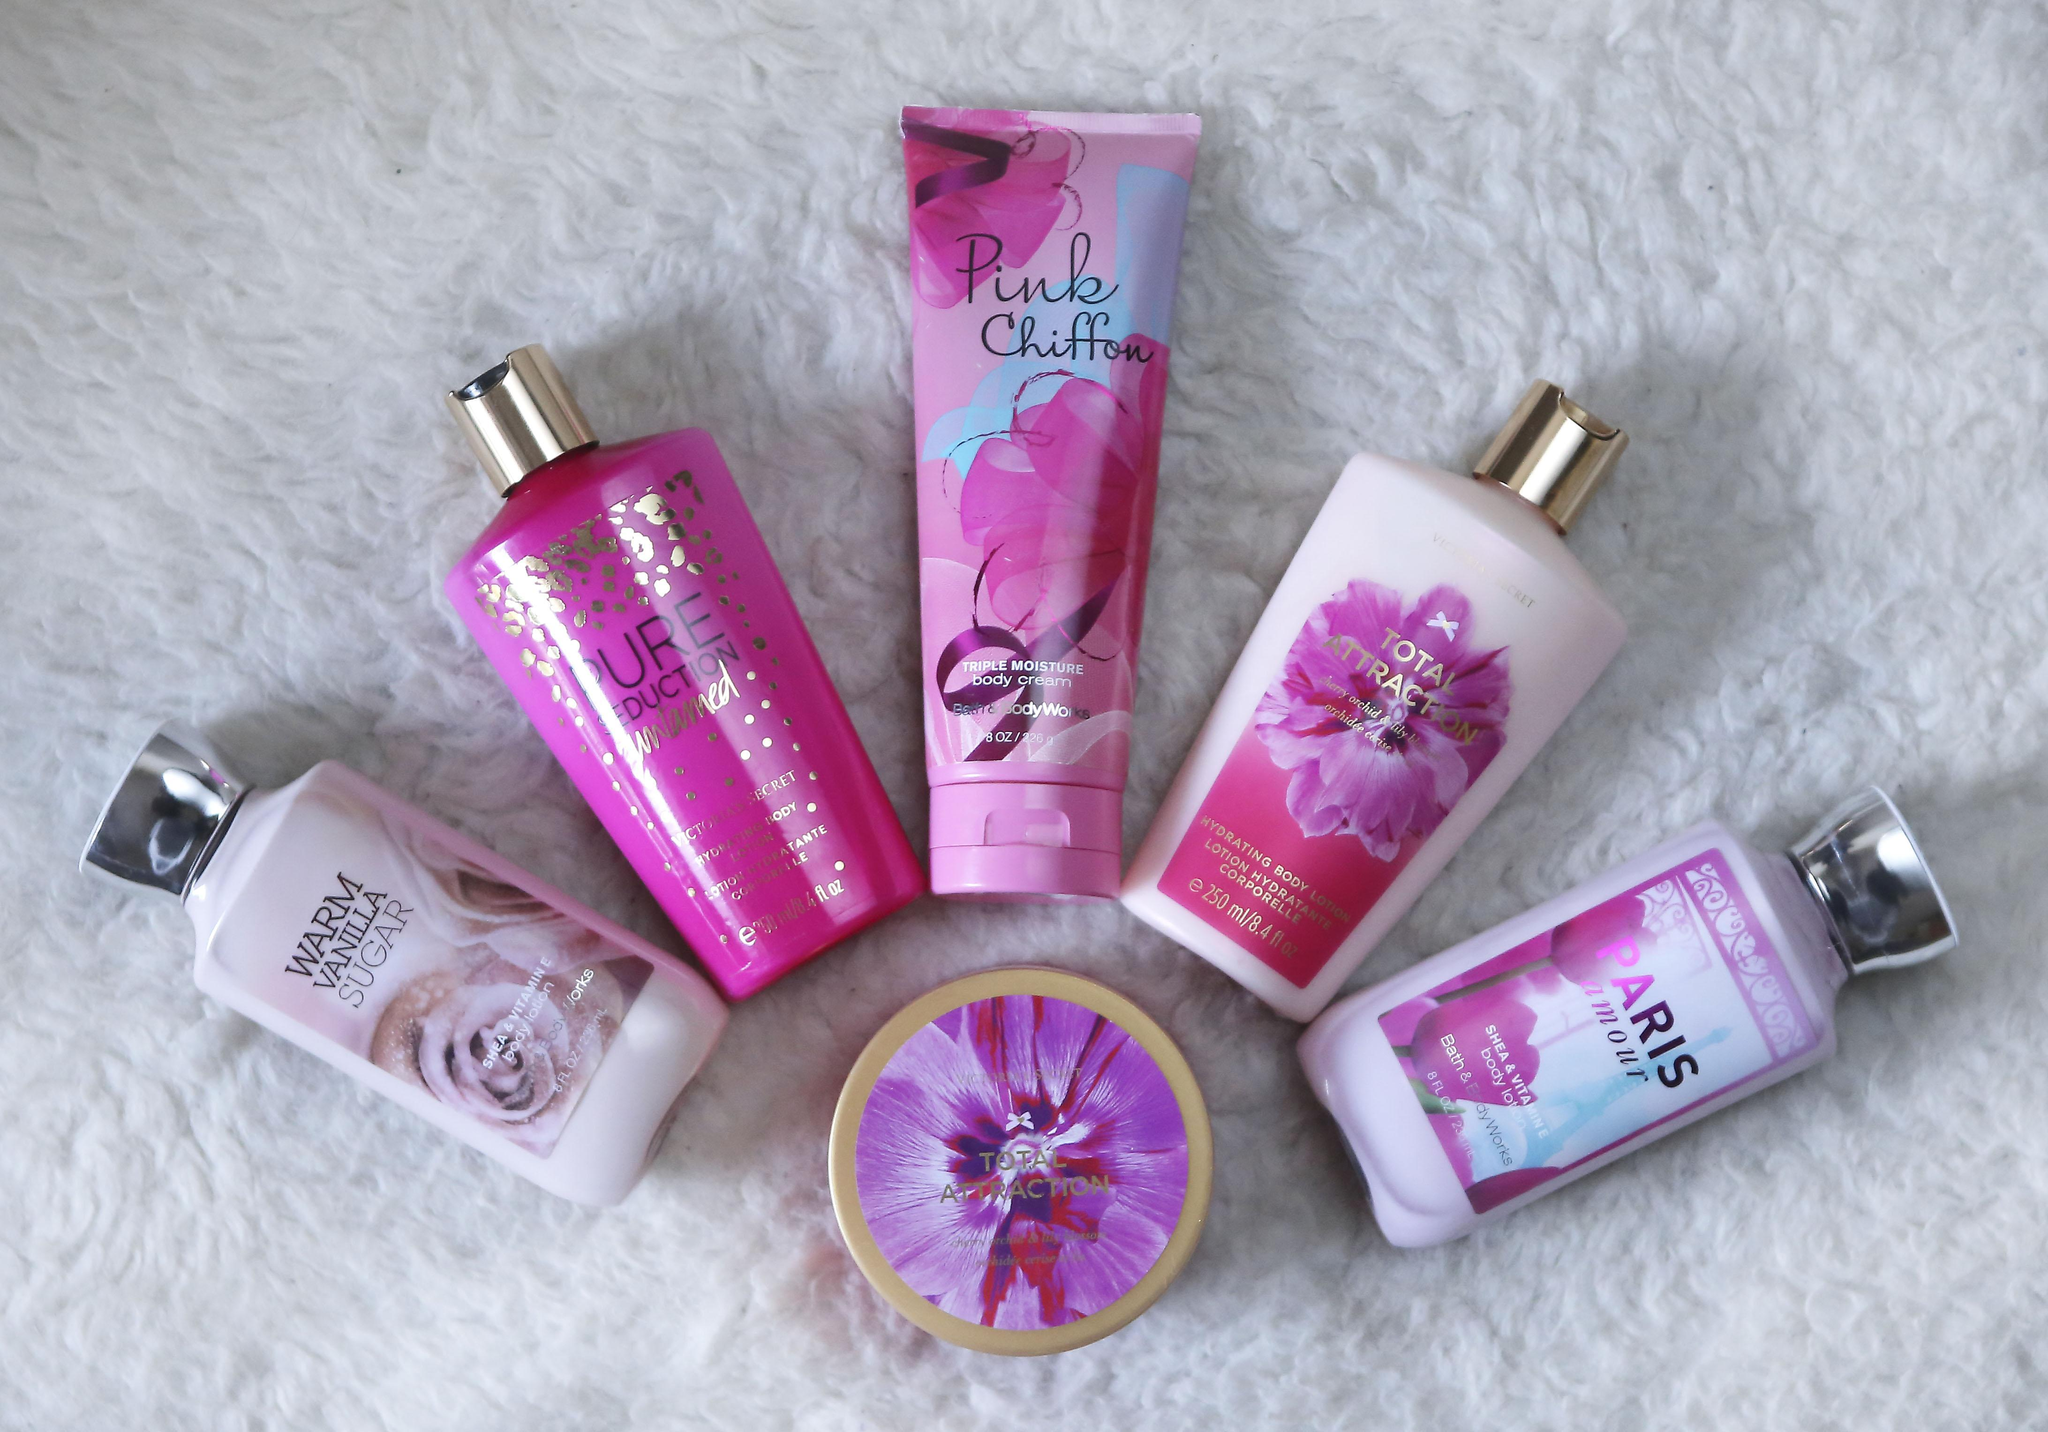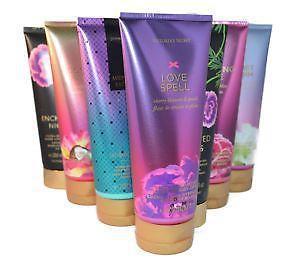The first image is the image on the left, the second image is the image on the right. Assess this claim about the two images: "In one of the images there are seven containers lined up in a V shape.". Correct or not? Answer yes or no. Yes. 